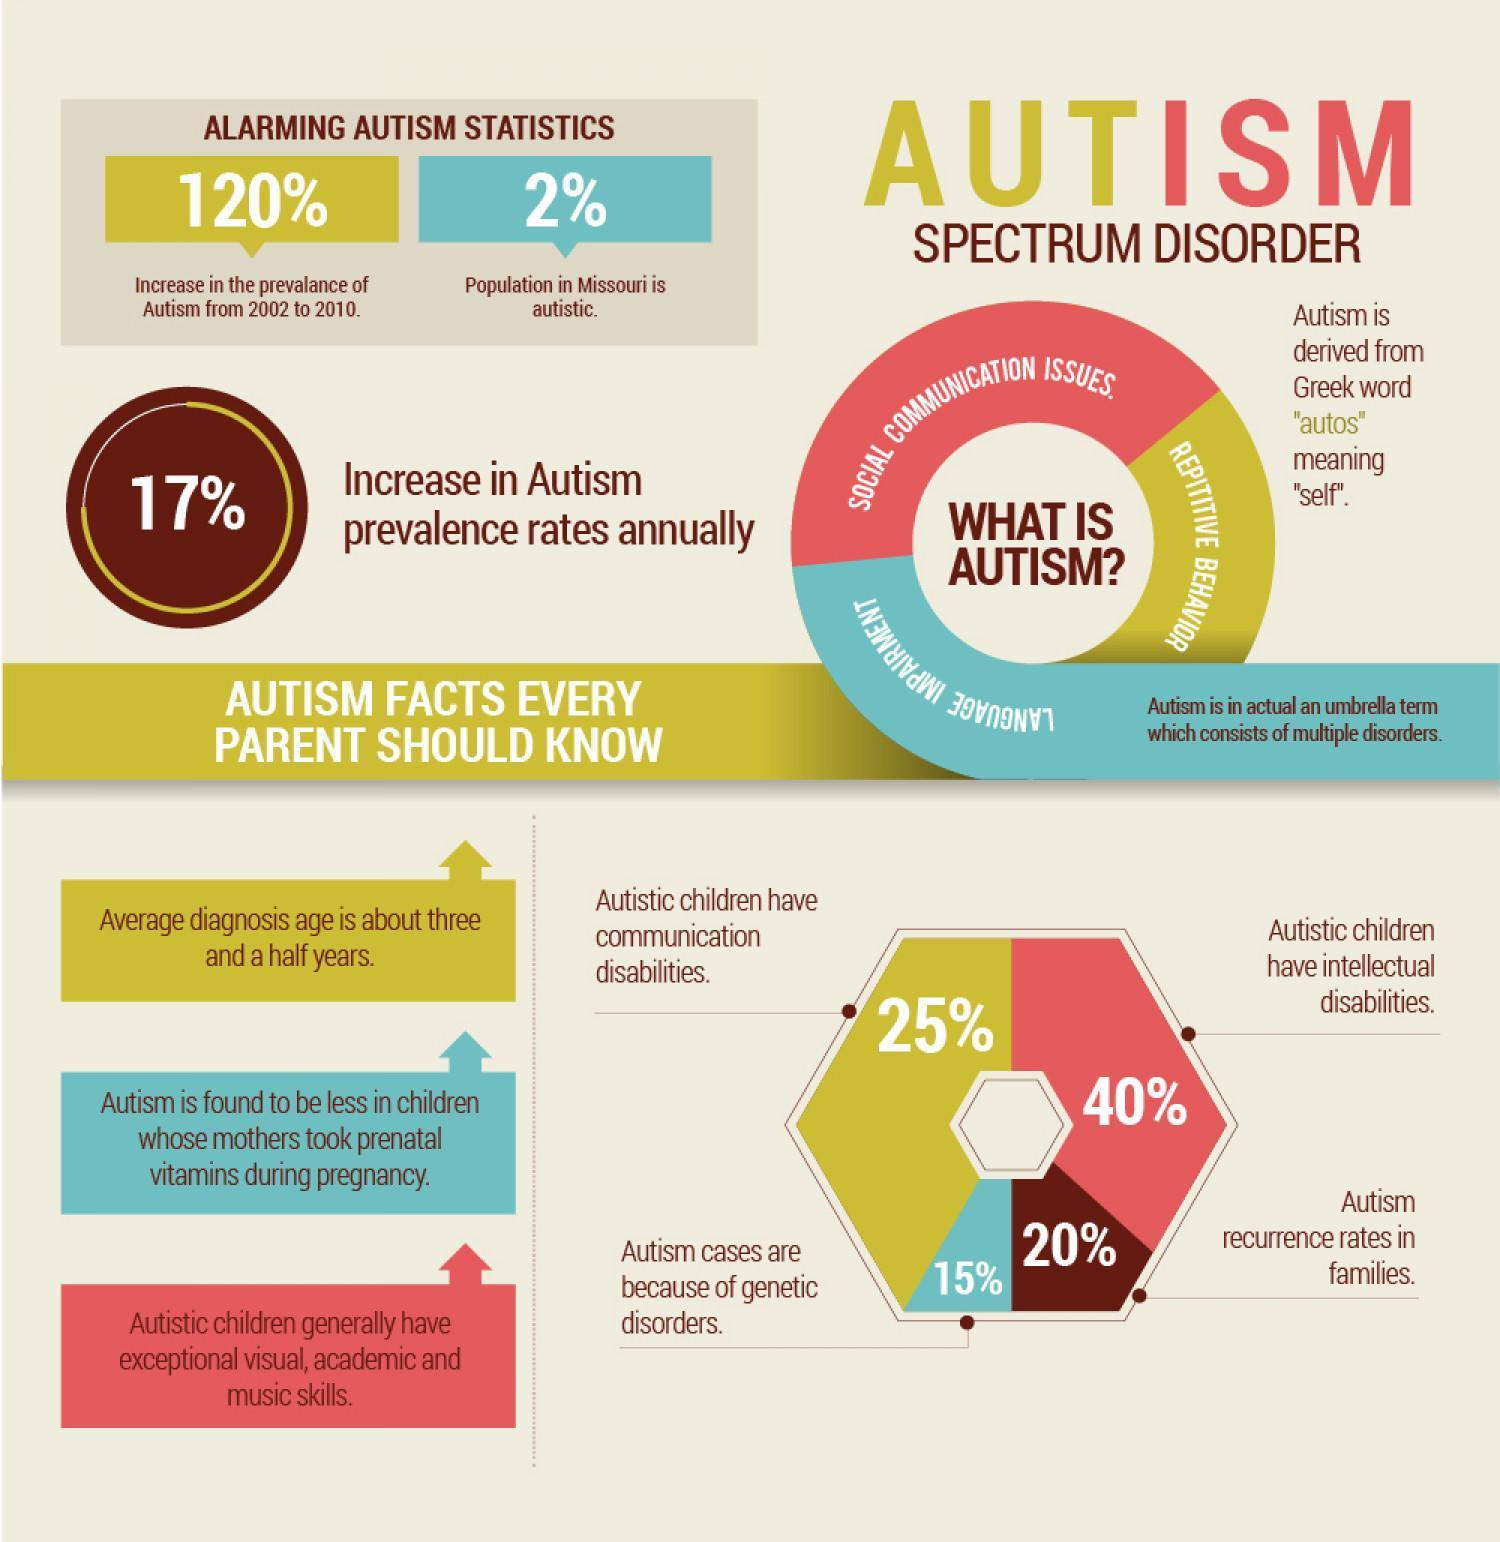What percentage of autism cases are because of genetic disorders?
Answer the question with a short phrase. 15% What percentage of increase is found in autism prevalences rates annually? 17% What percentage of population in Missouri is autistic? 2% What is the average diagnosis age of autism? about three and a half years. What percentage of Autistic children have intellectual disabilities? 40% What is the meaning of 'autos' in greek? "self' What percentage of autism children have communication disabilities? 25% 